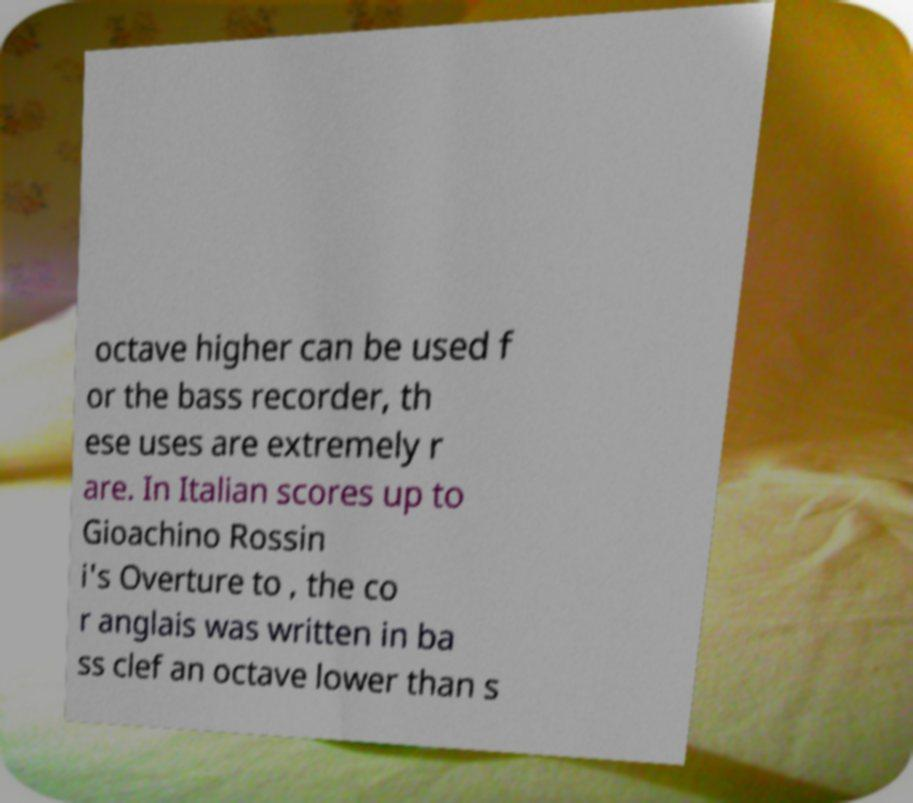Please identify and transcribe the text found in this image. octave higher can be used f or the bass recorder, th ese uses are extremely r are. In Italian scores up to Gioachino Rossin i's Overture to , the co r anglais was written in ba ss clef an octave lower than s 